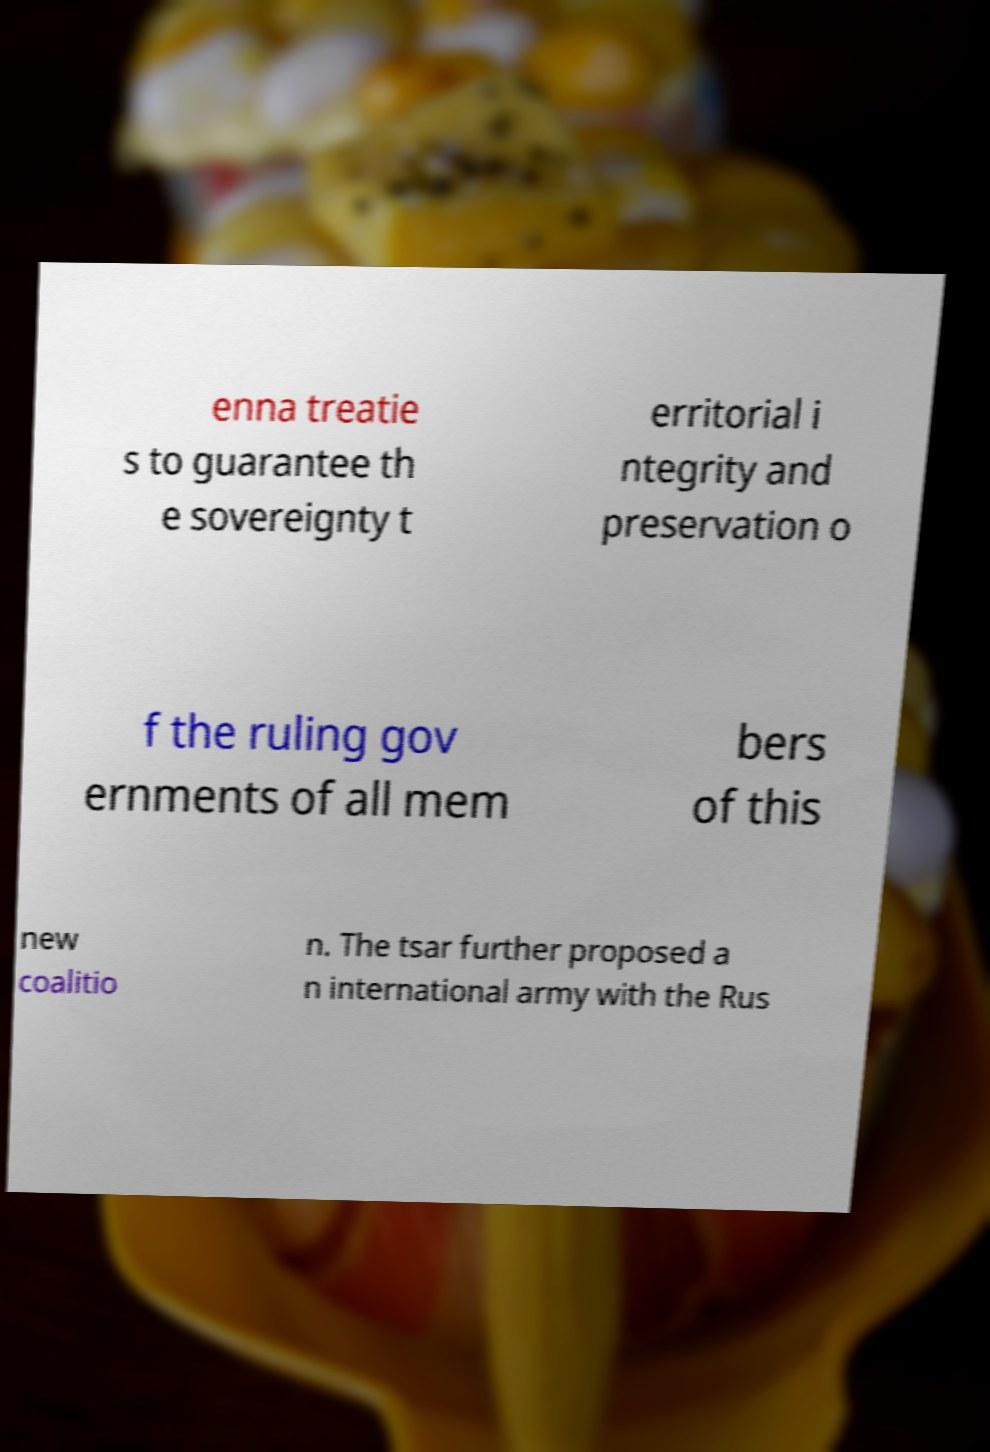For documentation purposes, I need the text within this image transcribed. Could you provide that? enna treatie s to guarantee th e sovereignty t erritorial i ntegrity and preservation o f the ruling gov ernments of all mem bers of this new coalitio n. The tsar further proposed a n international army with the Rus 